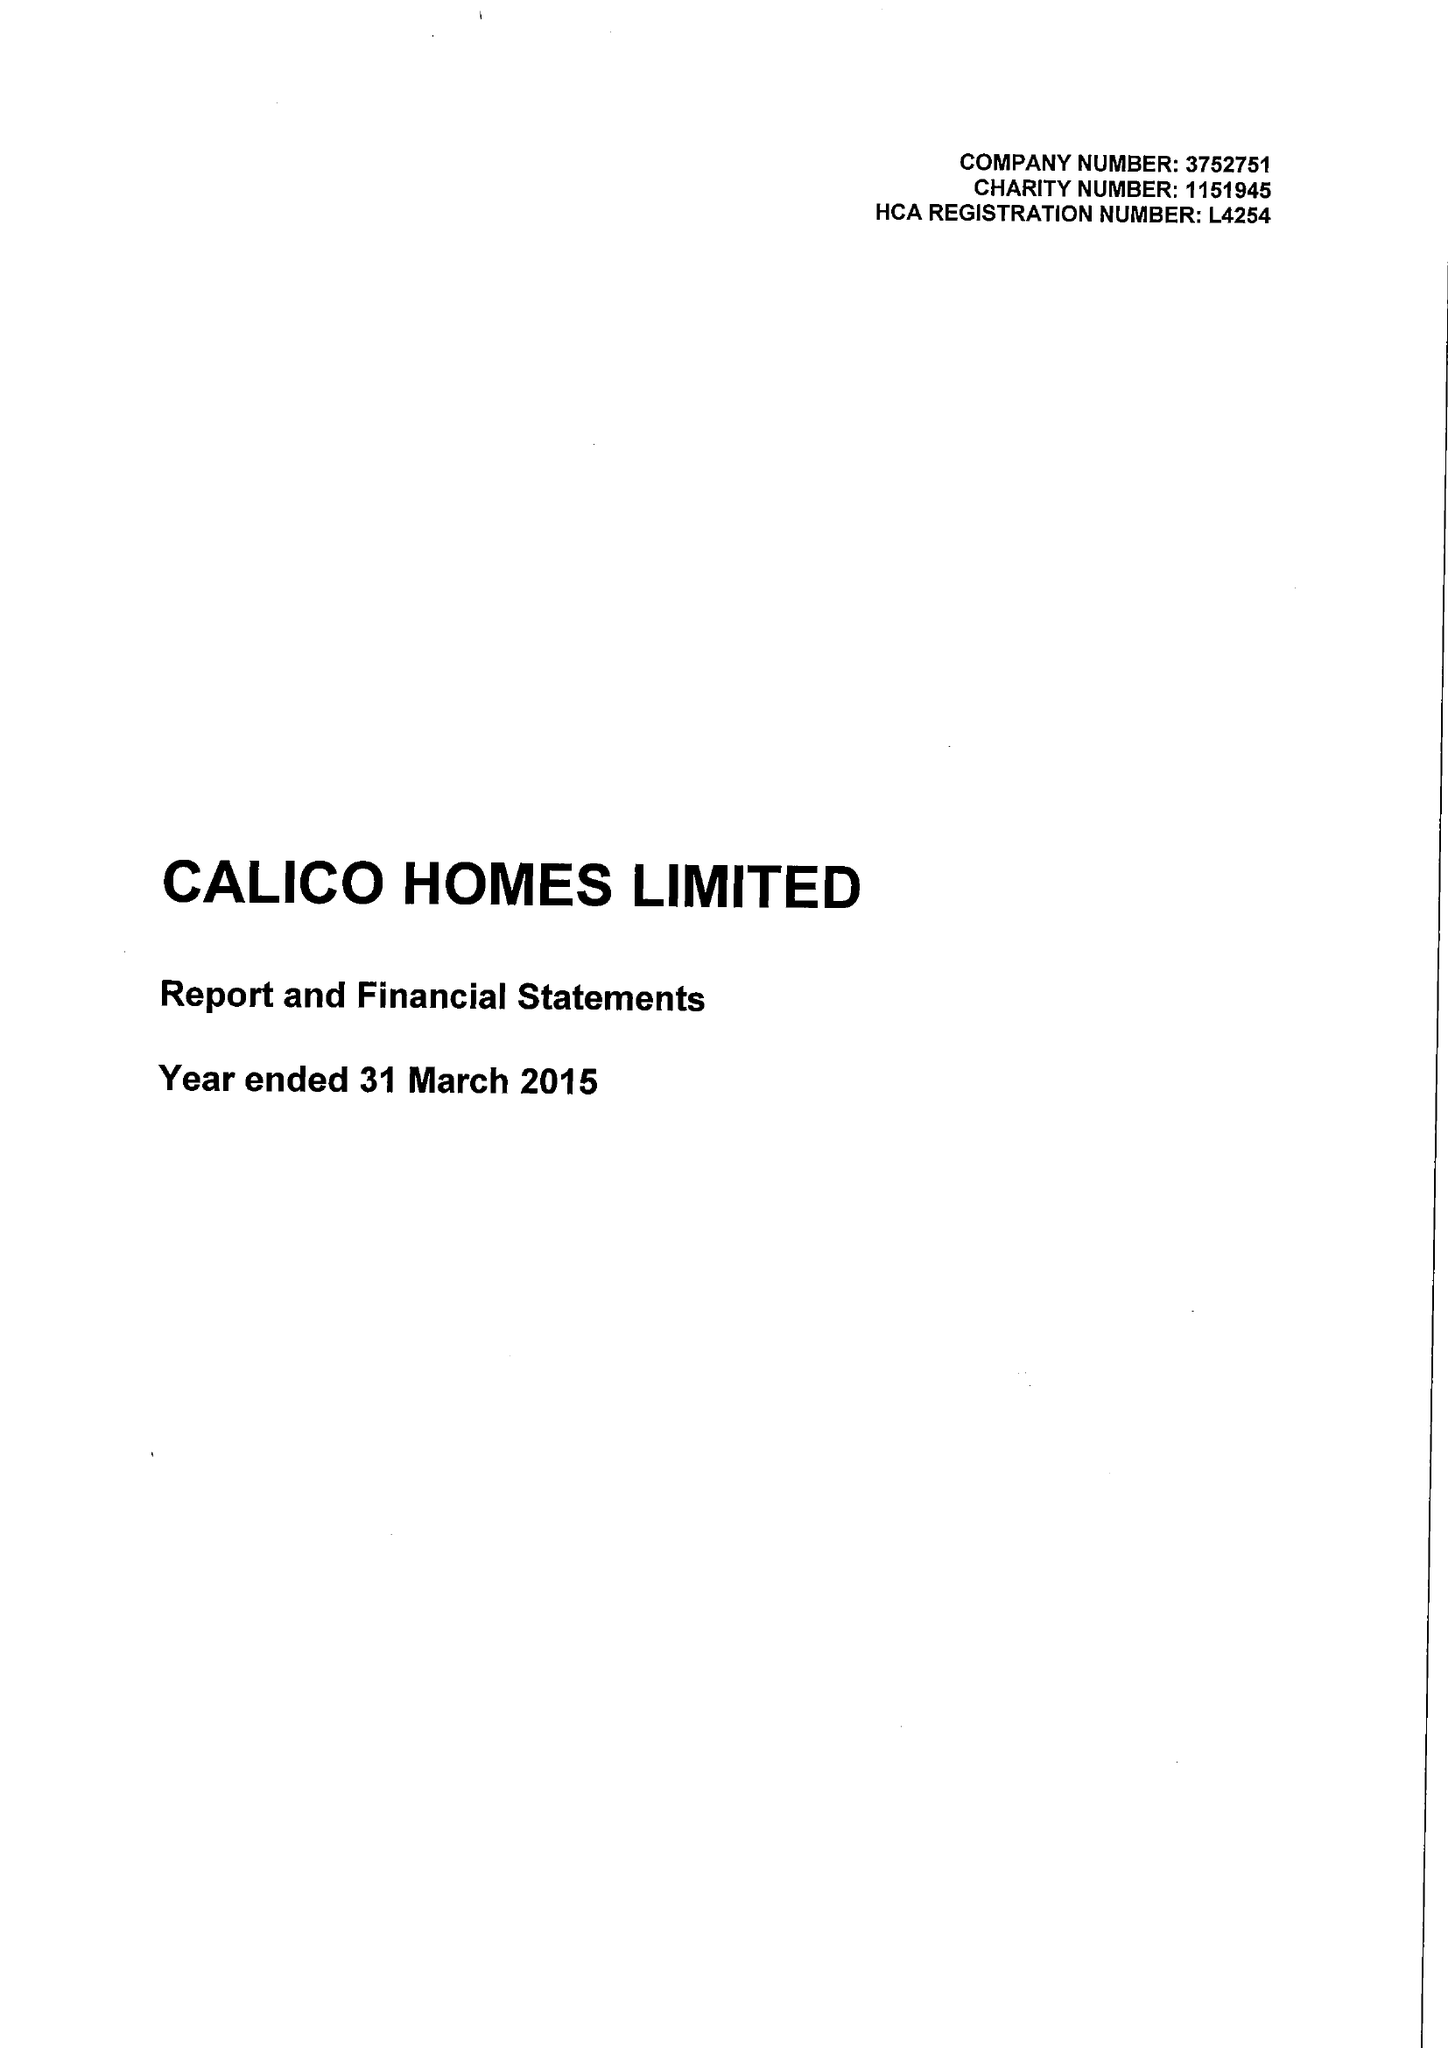What is the value for the charity_name?
Answer the question using a single word or phrase. Calico Homes Ltd. 